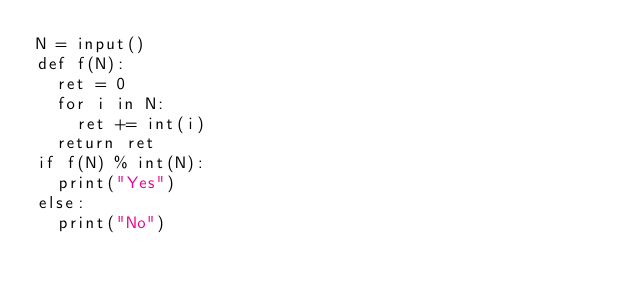Convert code to text. <code><loc_0><loc_0><loc_500><loc_500><_Python_>N = input()
def f(N):
  ret = 0
  for i in N:
    ret += int(i)
  return ret
if f(N) % int(N):
  print("Yes")
else:
  print("No")</code> 